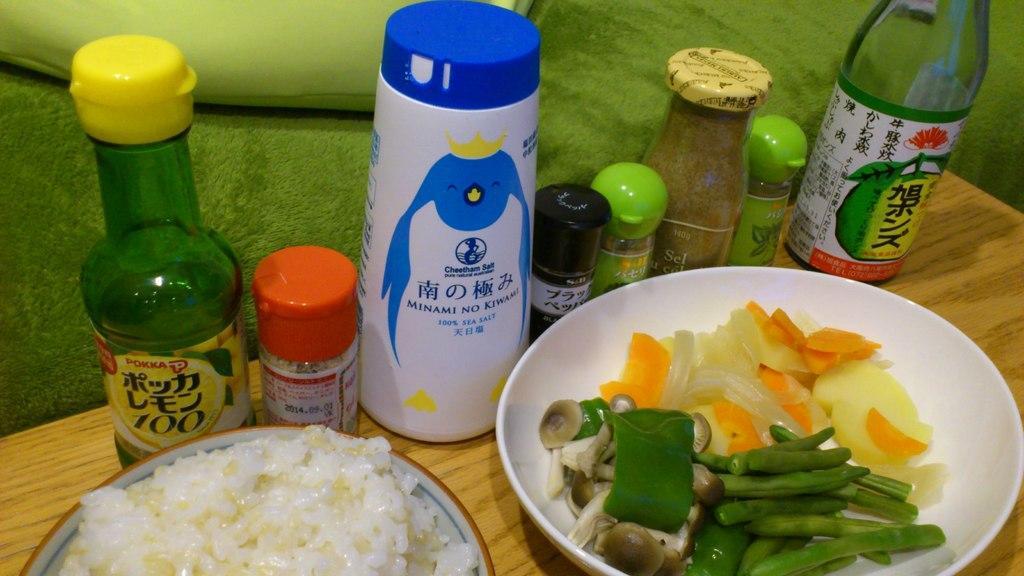In one or two sentences, can you explain what this image depicts? In the image we can see on table there is a bowl in which there are food items which are boiled and in a bowl there is rice cooked rice and there are bottles in which there are liquids and other spices for the food item. The table is made up of wood. 